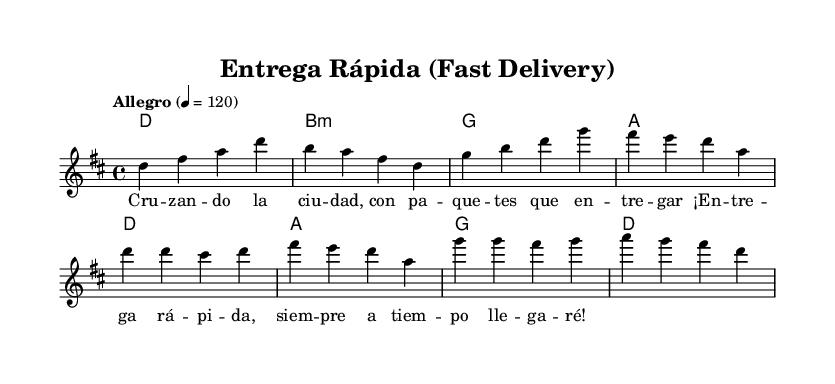What is the key signature of this music? The key signature is D major, which has two sharps (F# and C#). This can be determined by looking at the key signature indicated at the beginning of the score.
Answer: D major What is the time signature of this music? The time signature is 4/4, which means there are four beats in each measure and the quarter note gets one beat. This is visually indicated in the upper left corner of the score.
Answer: 4/4 What is the tempo marking of this music? The tempo marking indicates "Allegro," which suggests a lively and fast pace. This is specified in the tempo indication at the beginning of the score.
Answer: Allegro How many measures are in the verse section? The verse section consists of four measures, which can be counted by examining the series of notes and measures in that section of the music.
Answer: 4 Which chord follows the D major chord in the verse? The chord following the D major is B minor, identifiable by the chord symbols written above the staff in the verse section.
Answer: B minor What is the lyrical theme of the chorus? The lyrical theme of the chorus revolves around "fast delivery," as indicated by the lyrics that translate to "Fast delivery, always on time will arrive!" found in the chorus section.
Answer: Fast delivery What element in this piece reflects typical Latin American pop music? The rhythmic structure and upbeat tempo reflect the lively and danceable nature characteristic of Latin American pop music, visible in the rhythmic patterns and tempo marking.
Answer: Upbeat tempo 